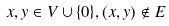Convert formula to latex. <formula><loc_0><loc_0><loc_500><loc_500>x , y \in V \cup \{ 0 \} , ( x , y ) \notin E</formula> 